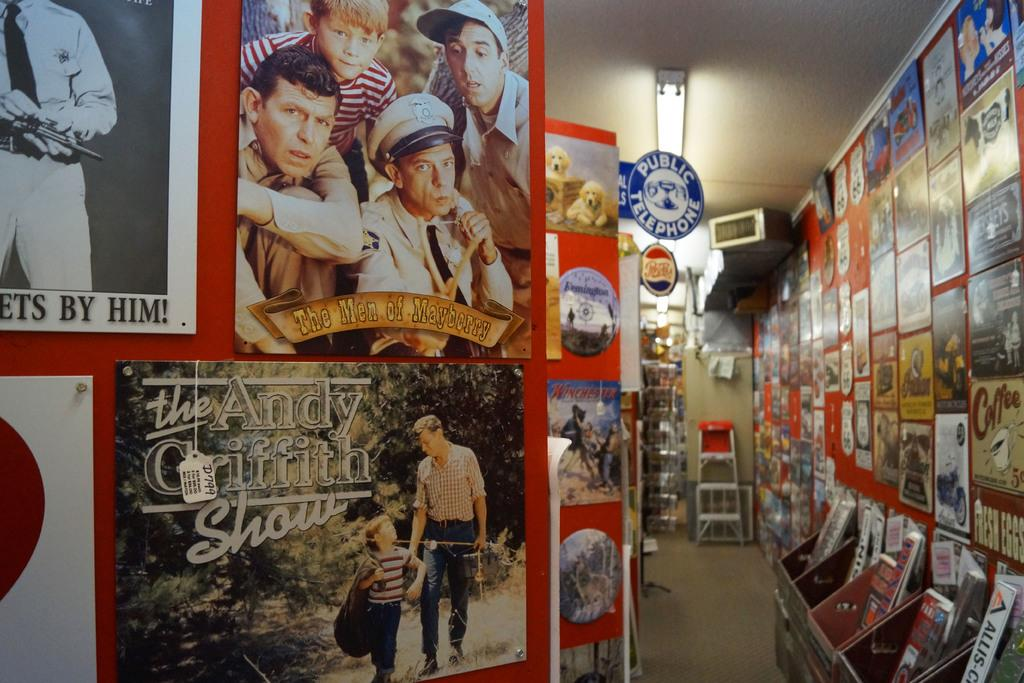Where is the image taken? The image is inside a store. What can be seen on the walls of the store? There are posters attached to the wall. What items are displayed in the store? There is a collection of books in front of one of the walls. What channel is the store broadcasting on television? There is no television present in the image, so it is not possible to determine what channel the store might be broadcasting. 